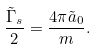Convert formula to latex. <formula><loc_0><loc_0><loc_500><loc_500>\frac { \tilde { \Gamma } _ { s } } { 2 } = \frac { 4 \pi \tilde { a } _ { 0 } } { m } .</formula> 